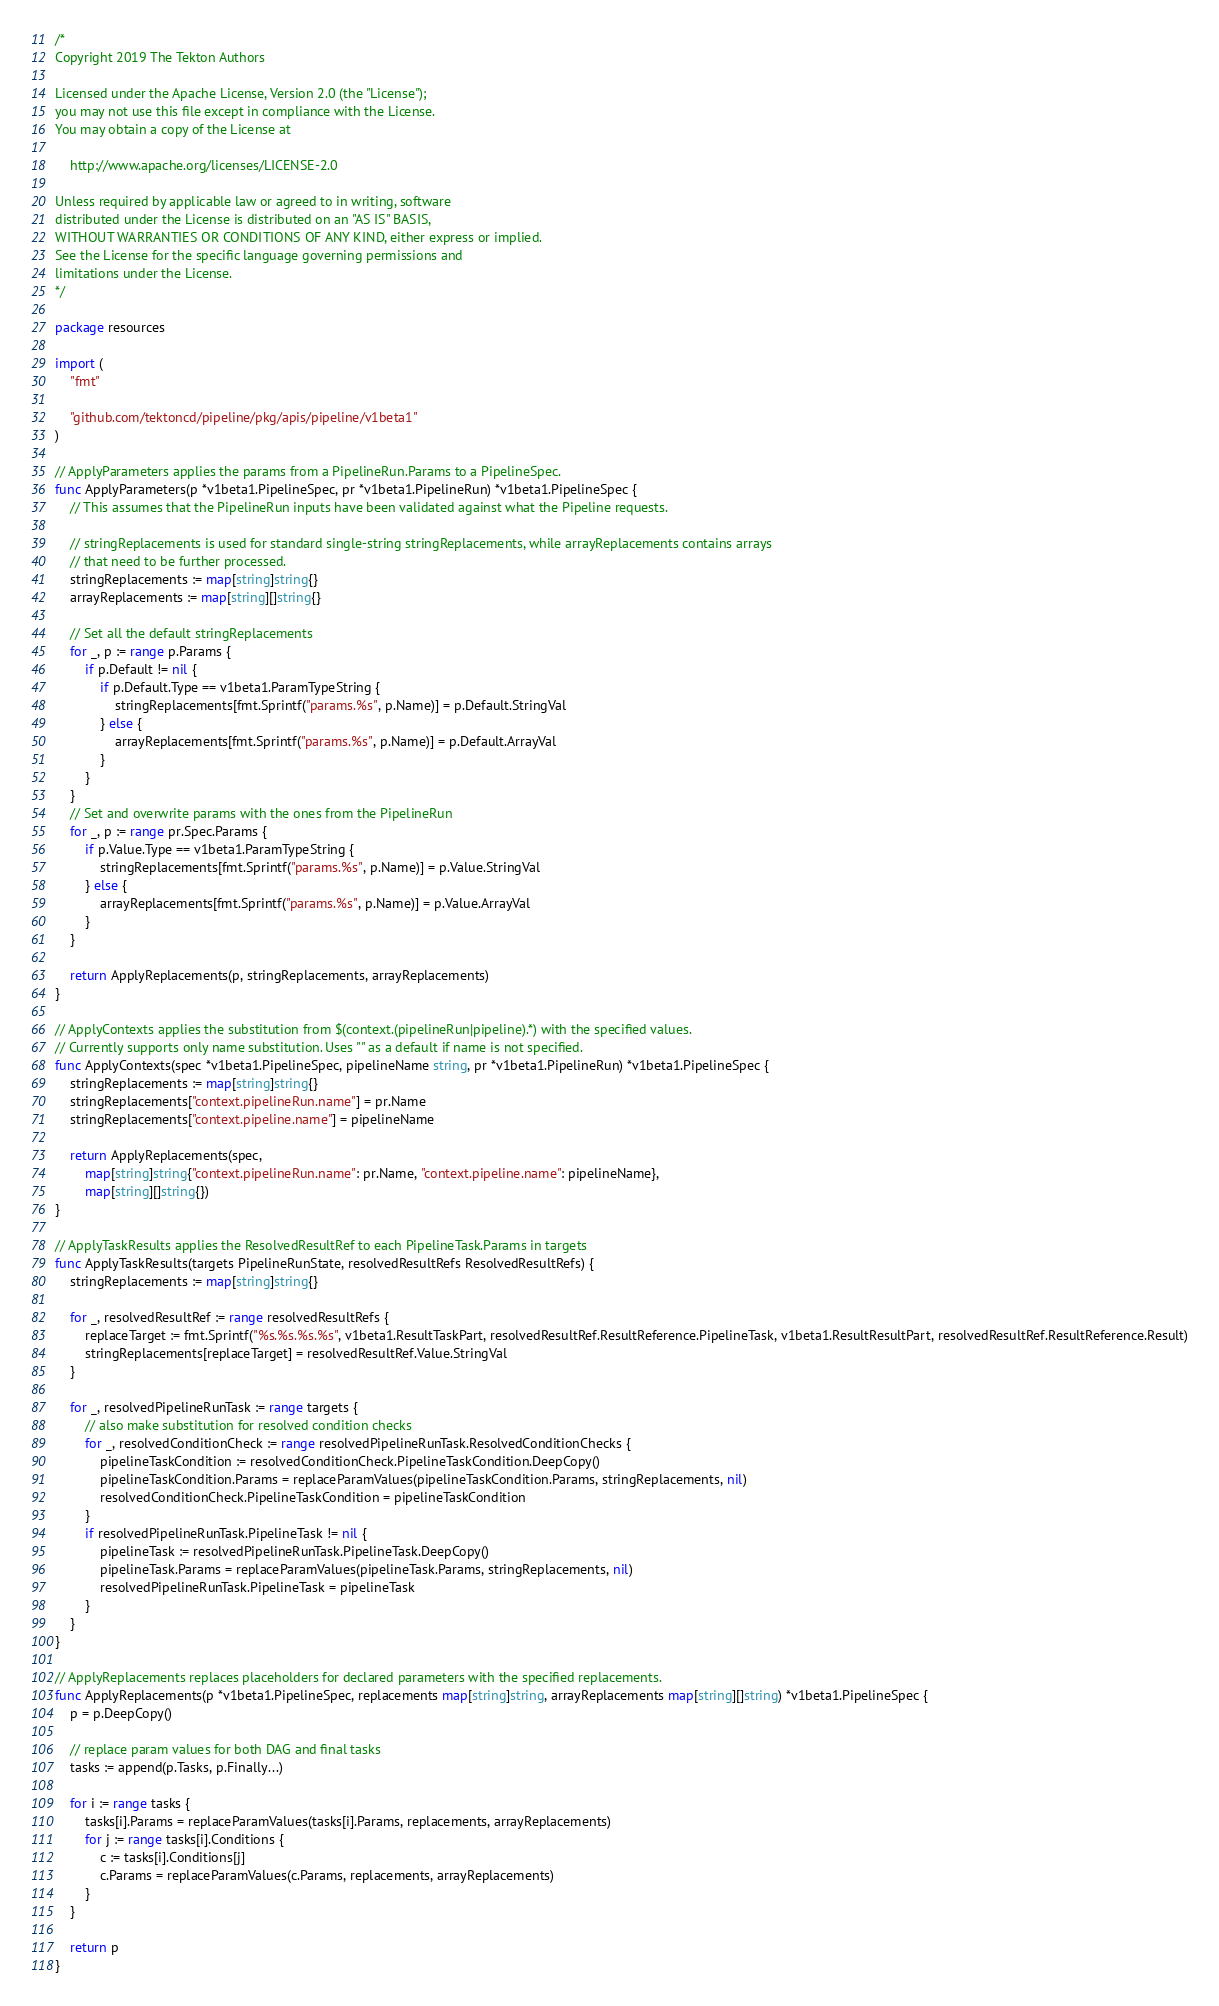<code> <loc_0><loc_0><loc_500><loc_500><_Go_>/*
Copyright 2019 The Tekton Authors

Licensed under the Apache License, Version 2.0 (the "License");
you may not use this file except in compliance with the License.
You may obtain a copy of the License at

    http://www.apache.org/licenses/LICENSE-2.0

Unless required by applicable law or agreed to in writing, software
distributed under the License is distributed on an "AS IS" BASIS,
WITHOUT WARRANTIES OR CONDITIONS OF ANY KIND, either express or implied.
See the License for the specific language governing permissions and
limitations under the License.
*/

package resources

import (
	"fmt"

	"github.com/tektoncd/pipeline/pkg/apis/pipeline/v1beta1"
)

// ApplyParameters applies the params from a PipelineRun.Params to a PipelineSpec.
func ApplyParameters(p *v1beta1.PipelineSpec, pr *v1beta1.PipelineRun) *v1beta1.PipelineSpec {
	// This assumes that the PipelineRun inputs have been validated against what the Pipeline requests.

	// stringReplacements is used for standard single-string stringReplacements, while arrayReplacements contains arrays
	// that need to be further processed.
	stringReplacements := map[string]string{}
	arrayReplacements := map[string][]string{}

	// Set all the default stringReplacements
	for _, p := range p.Params {
		if p.Default != nil {
			if p.Default.Type == v1beta1.ParamTypeString {
				stringReplacements[fmt.Sprintf("params.%s", p.Name)] = p.Default.StringVal
			} else {
				arrayReplacements[fmt.Sprintf("params.%s", p.Name)] = p.Default.ArrayVal
			}
		}
	}
	// Set and overwrite params with the ones from the PipelineRun
	for _, p := range pr.Spec.Params {
		if p.Value.Type == v1beta1.ParamTypeString {
			stringReplacements[fmt.Sprintf("params.%s", p.Name)] = p.Value.StringVal
		} else {
			arrayReplacements[fmt.Sprintf("params.%s", p.Name)] = p.Value.ArrayVal
		}
	}

	return ApplyReplacements(p, stringReplacements, arrayReplacements)
}

// ApplyContexts applies the substitution from $(context.(pipelineRun|pipeline).*) with the specified values.
// Currently supports only name substitution. Uses "" as a default if name is not specified.
func ApplyContexts(spec *v1beta1.PipelineSpec, pipelineName string, pr *v1beta1.PipelineRun) *v1beta1.PipelineSpec {
	stringReplacements := map[string]string{}
	stringReplacements["context.pipelineRun.name"] = pr.Name
	stringReplacements["context.pipeline.name"] = pipelineName

	return ApplyReplacements(spec,
		map[string]string{"context.pipelineRun.name": pr.Name, "context.pipeline.name": pipelineName},
		map[string][]string{})
}

// ApplyTaskResults applies the ResolvedResultRef to each PipelineTask.Params in targets
func ApplyTaskResults(targets PipelineRunState, resolvedResultRefs ResolvedResultRefs) {
	stringReplacements := map[string]string{}

	for _, resolvedResultRef := range resolvedResultRefs {
		replaceTarget := fmt.Sprintf("%s.%s.%s.%s", v1beta1.ResultTaskPart, resolvedResultRef.ResultReference.PipelineTask, v1beta1.ResultResultPart, resolvedResultRef.ResultReference.Result)
		stringReplacements[replaceTarget] = resolvedResultRef.Value.StringVal
	}

	for _, resolvedPipelineRunTask := range targets {
		// also make substitution for resolved condition checks
		for _, resolvedConditionCheck := range resolvedPipelineRunTask.ResolvedConditionChecks {
			pipelineTaskCondition := resolvedConditionCheck.PipelineTaskCondition.DeepCopy()
			pipelineTaskCondition.Params = replaceParamValues(pipelineTaskCondition.Params, stringReplacements, nil)
			resolvedConditionCheck.PipelineTaskCondition = pipelineTaskCondition
		}
		if resolvedPipelineRunTask.PipelineTask != nil {
			pipelineTask := resolvedPipelineRunTask.PipelineTask.DeepCopy()
			pipelineTask.Params = replaceParamValues(pipelineTask.Params, stringReplacements, nil)
			resolvedPipelineRunTask.PipelineTask = pipelineTask
		}
	}
}

// ApplyReplacements replaces placeholders for declared parameters with the specified replacements.
func ApplyReplacements(p *v1beta1.PipelineSpec, replacements map[string]string, arrayReplacements map[string][]string) *v1beta1.PipelineSpec {
	p = p.DeepCopy()

	// replace param values for both DAG and final tasks
	tasks := append(p.Tasks, p.Finally...)

	for i := range tasks {
		tasks[i].Params = replaceParamValues(tasks[i].Params, replacements, arrayReplacements)
		for j := range tasks[i].Conditions {
			c := tasks[i].Conditions[j]
			c.Params = replaceParamValues(c.Params, replacements, arrayReplacements)
		}
	}

	return p
}
</code> 